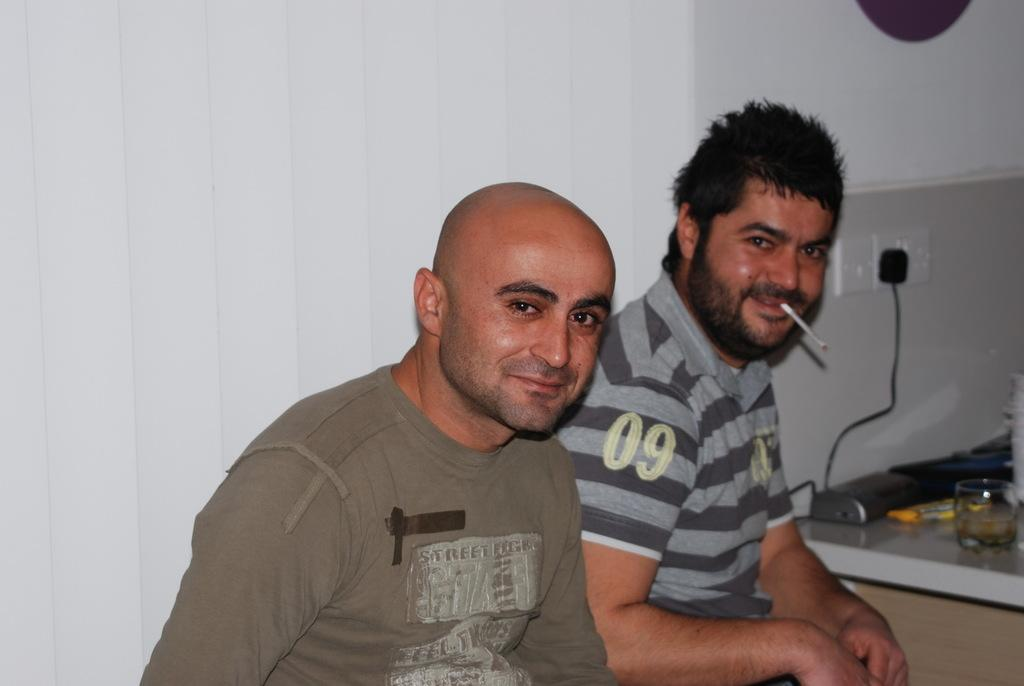How many plug sockets are visible in the image? There are two plug sockets in the image. What is the relationship between one of the plug sockets and an extension box? One of the plug sockets is plugged into an extension box. What are the people in the image doing? There are two persons sitting on a chair in the image, and one of them is smoking. Can you see any stamps on the sidewalk in the image? There is no sidewalk or stamps present in the image. How many pins are being used by the person smoking in the image? There is no mention of pins in the image, and the person is smoking. 